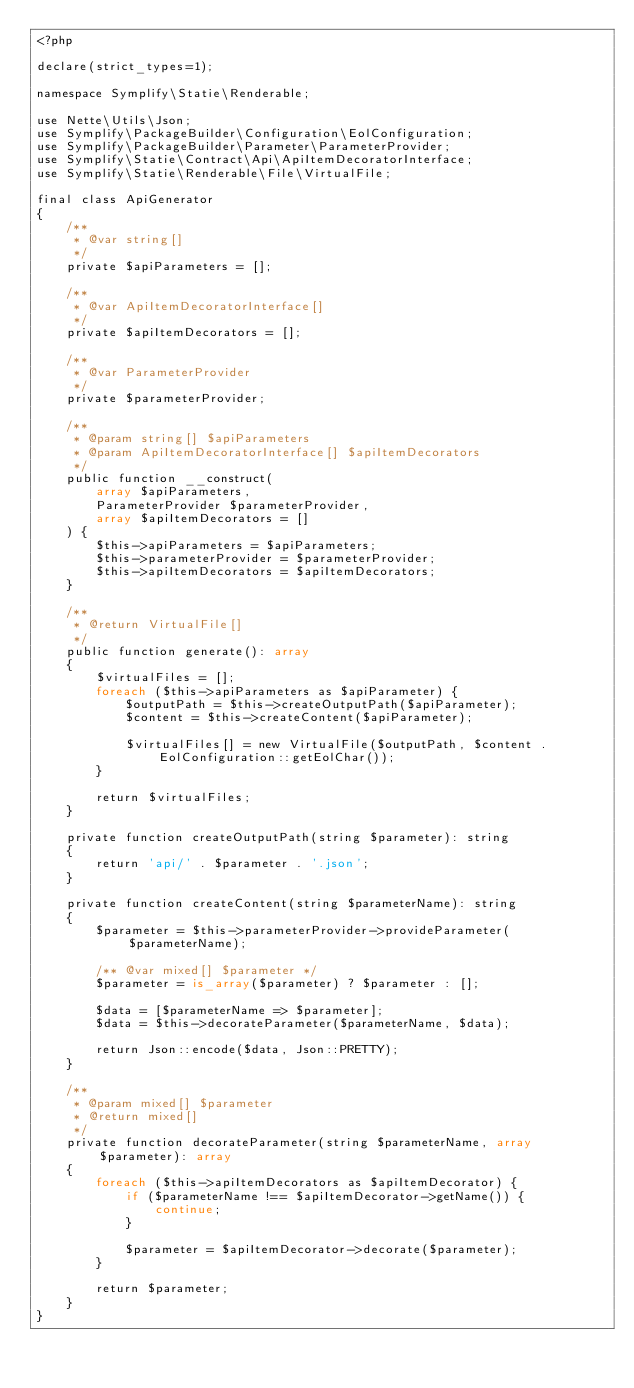<code> <loc_0><loc_0><loc_500><loc_500><_PHP_><?php

declare(strict_types=1);

namespace Symplify\Statie\Renderable;

use Nette\Utils\Json;
use Symplify\PackageBuilder\Configuration\EolConfiguration;
use Symplify\PackageBuilder\Parameter\ParameterProvider;
use Symplify\Statie\Contract\Api\ApiItemDecoratorInterface;
use Symplify\Statie\Renderable\File\VirtualFile;

final class ApiGenerator
{
    /**
     * @var string[]
     */
    private $apiParameters = [];

    /**
     * @var ApiItemDecoratorInterface[]
     */
    private $apiItemDecorators = [];

    /**
     * @var ParameterProvider
     */
    private $parameterProvider;

    /**
     * @param string[] $apiParameters
     * @param ApiItemDecoratorInterface[] $apiItemDecorators
     */
    public function __construct(
        array $apiParameters,
        ParameterProvider $parameterProvider,
        array $apiItemDecorators = []
    ) {
        $this->apiParameters = $apiParameters;
        $this->parameterProvider = $parameterProvider;
        $this->apiItemDecorators = $apiItemDecorators;
    }

    /**
     * @return VirtualFile[]
     */
    public function generate(): array
    {
        $virtualFiles = [];
        foreach ($this->apiParameters as $apiParameter) {
            $outputPath = $this->createOutputPath($apiParameter);
            $content = $this->createContent($apiParameter);

            $virtualFiles[] = new VirtualFile($outputPath, $content . EolConfiguration::getEolChar());
        }

        return $virtualFiles;
    }

    private function createOutputPath(string $parameter): string
    {
        return 'api/' . $parameter . '.json';
    }

    private function createContent(string $parameterName): string
    {
        $parameter = $this->parameterProvider->provideParameter($parameterName);

        /** @var mixed[] $parameter */
        $parameter = is_array($parameter) ? $parameter : [];

        $data = [$parameterName => $parameter];
        $data = $this->decorateParameter($parameterName, $data);

        return Json::encode($data, Json::PRETTY);
    }

    /**
     * @param mixed[] $parameter
     * @return mixed[]
     */
    private function decorateParameter(string $parameterName, array $parameter): array
    {
        foreach ($this->apiItemDecorators as $apiItemDecorator) {
            if ($parameterName !== $apiItemDecorator->getName()) {
                continue;
            }

            $parameter = $apiItemDecorator->decorate($parameter);
        }

        return $parameter;
    }
}
</code> 